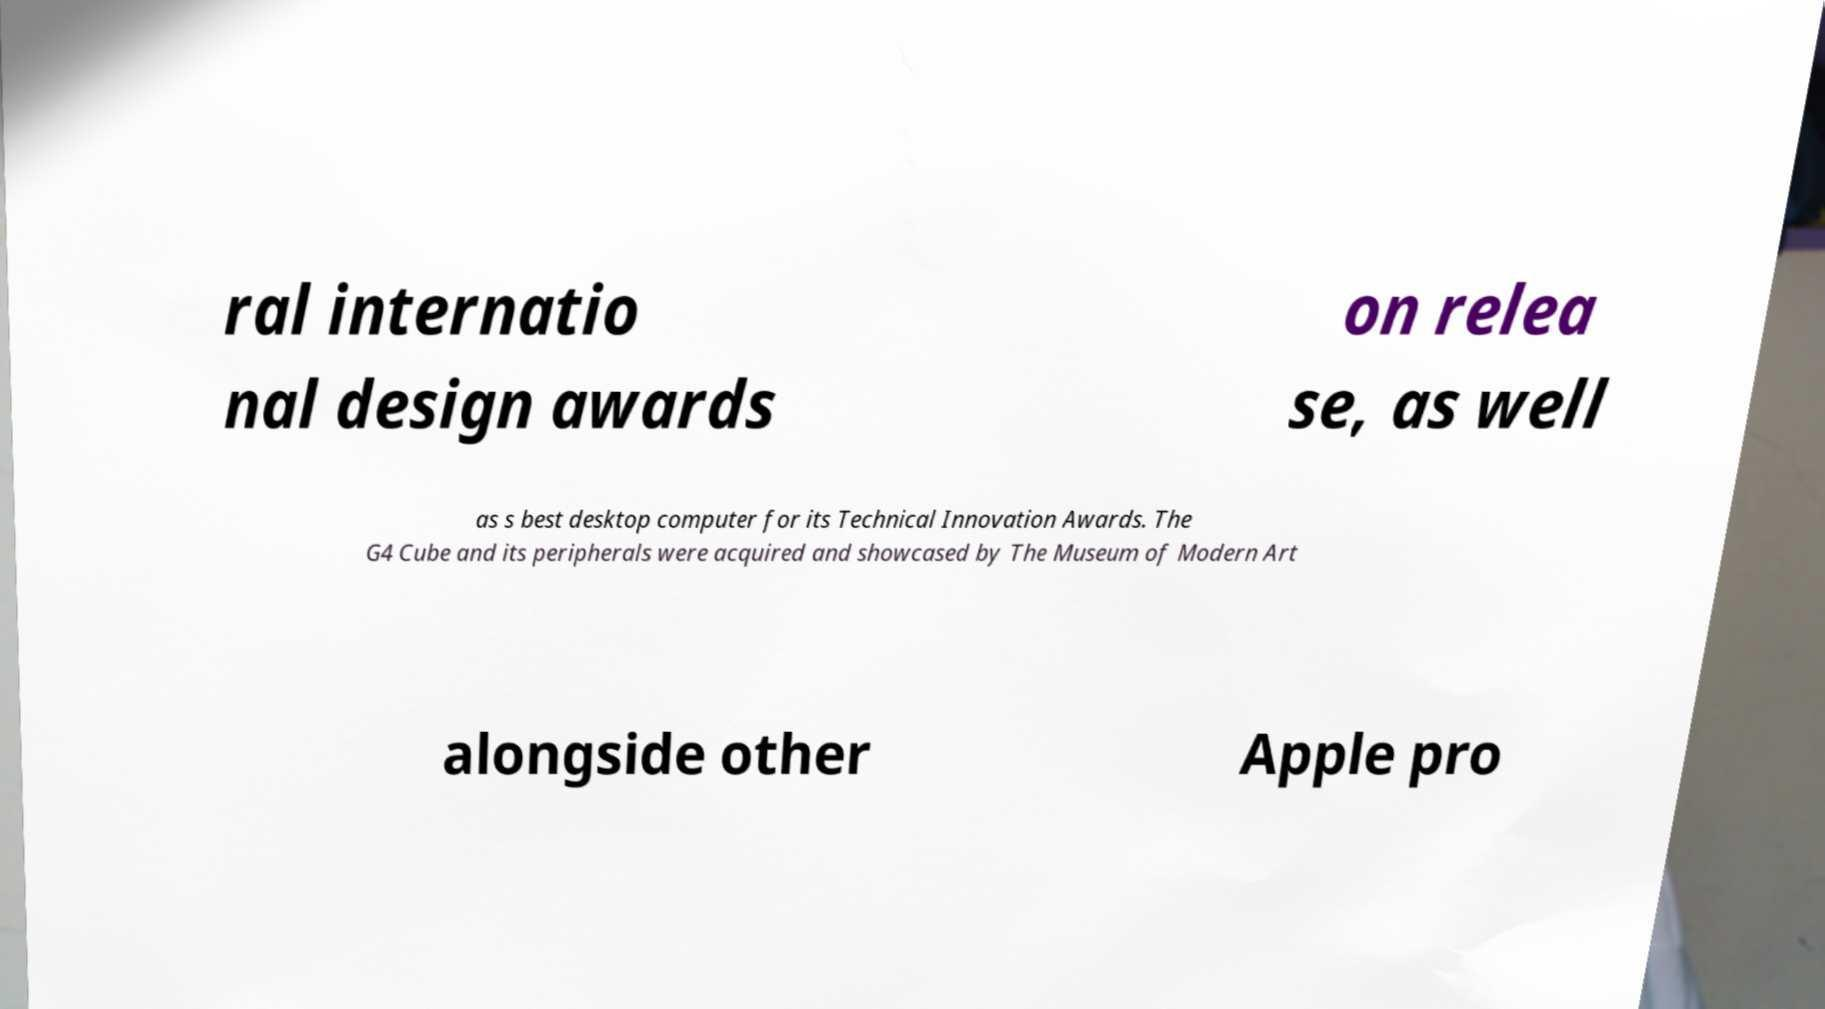Please identify and transcribe the text found in this image. ral internatio nal design awards on relea se, as well as s best desktop computer for its Technical Innovation Awards. The G4 Cube and its peripherals were acquired and showcased by The Museum of Modern Art alongside other Apple pro 